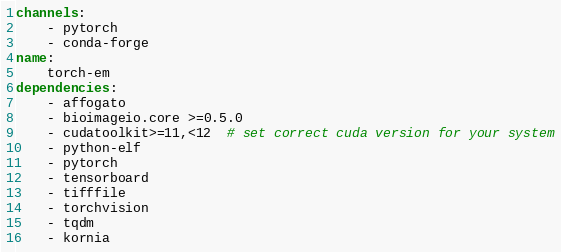Convert code to text. <code><loc_0><loc_0><loc_500><loc_500><_YAML_>channels:
    - pytorch
    - conda-forge
name:
    torch-em
dependencies:
    - affogato
    - bioimageio.core >=0.5.0
    - cudatoolkit>=11,<12  # set correct cuda version for your system
    - python-elf
    - pytorch
    - tensorboard
    - tifffile
    - torchvision
    - tqdm
    - kornia
</code> 